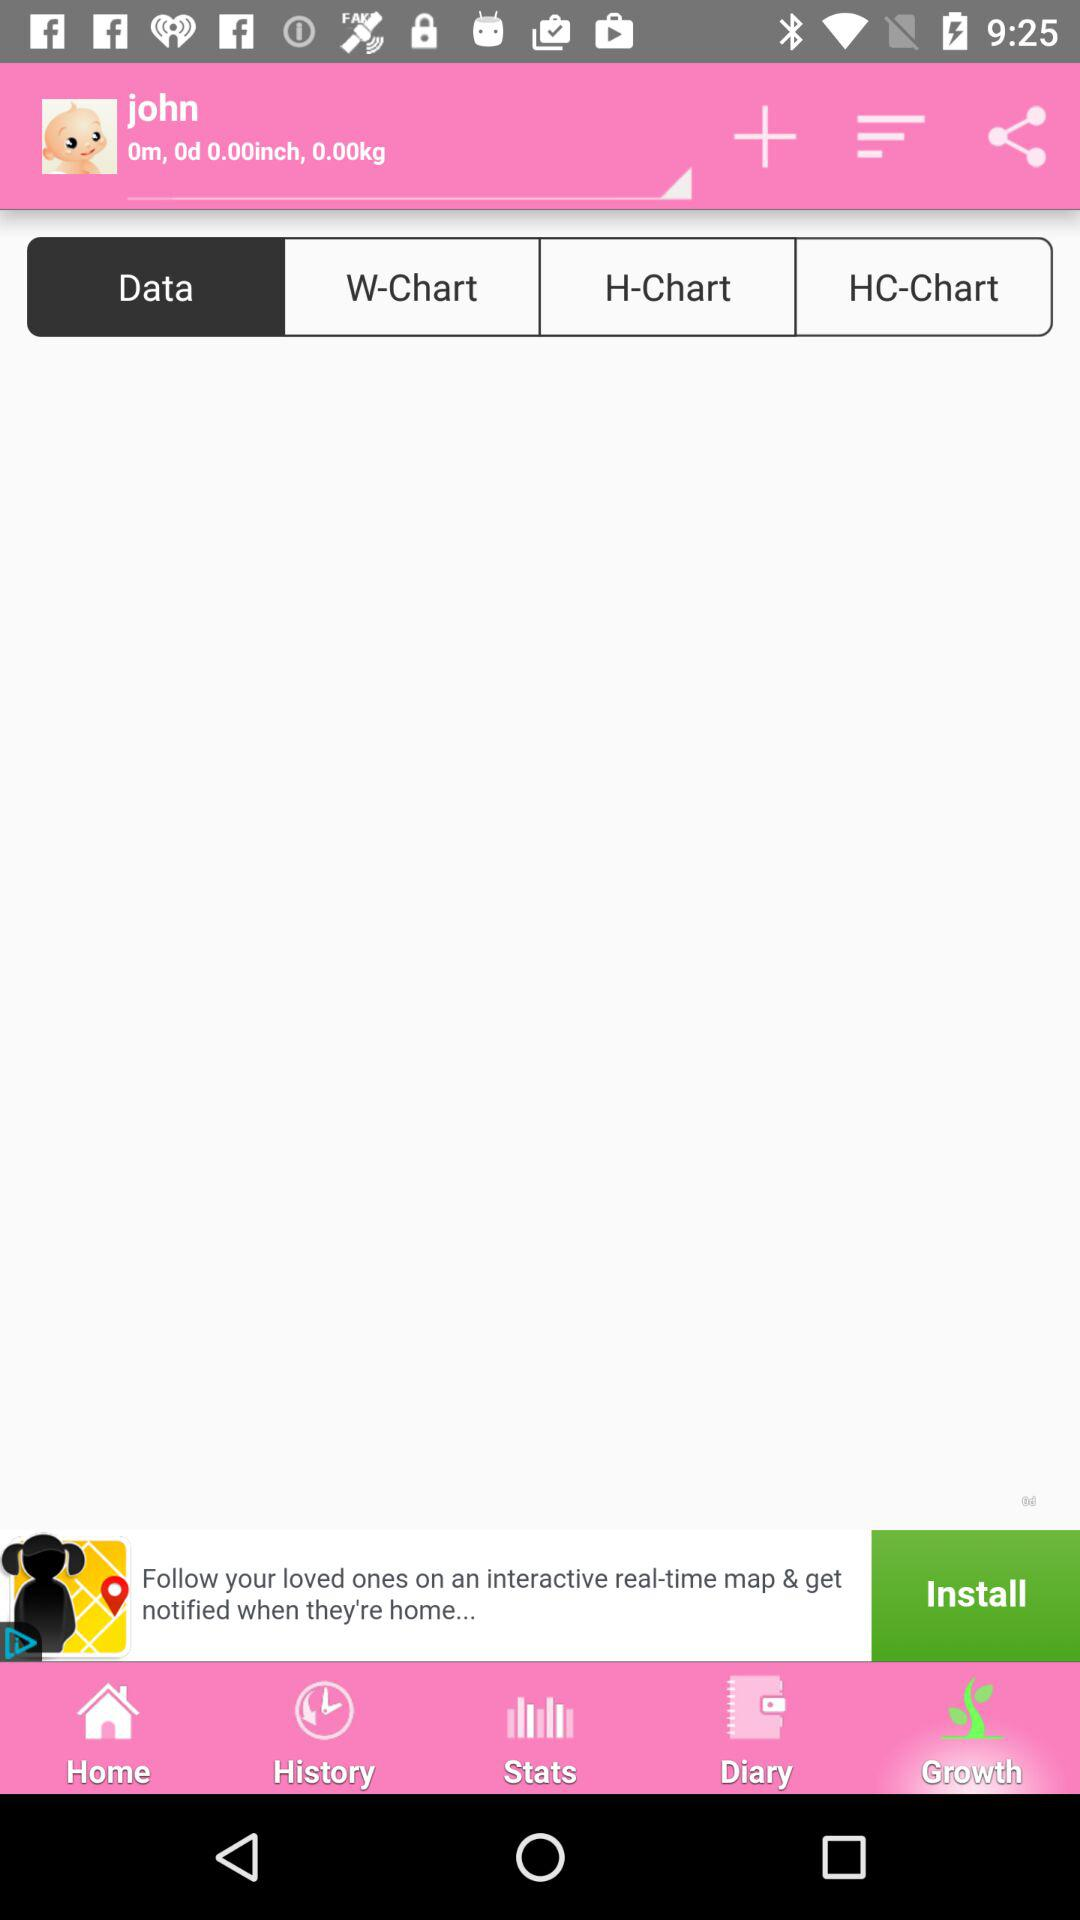What's the user name? The user name is John. 